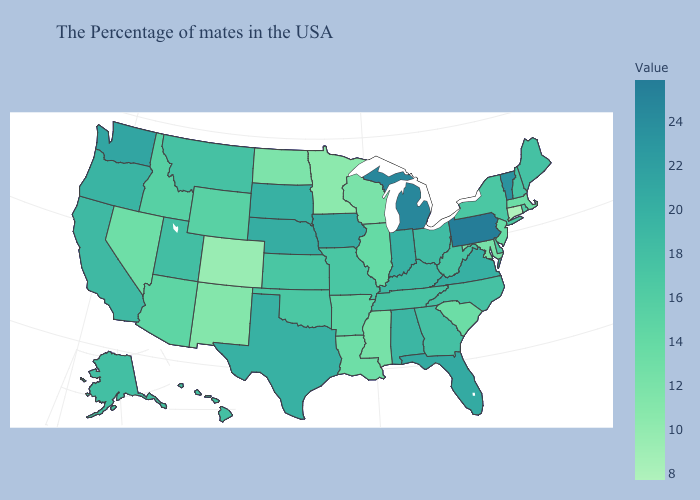Which states have the highest value in the USA?
Keep it brief. Pennsylvania. Which states have the lowest value in the South?
Be succinct. Maryland, Mississippi. Does Mississippi have the lowest value in the South?
Short answer required. Yes. Which states have the lowest value in the USA?
Keep it brief. Connecticut. Does Maryland have a higher value than New York?
Concise answer only. No. Which states have the lowest value in the USA?
Write a very short answer. Connecticut. Is the legend a continuous bar?
Keep it brief. Yes. Does Texas have the highest value in the South?
Quick response, please. No. 